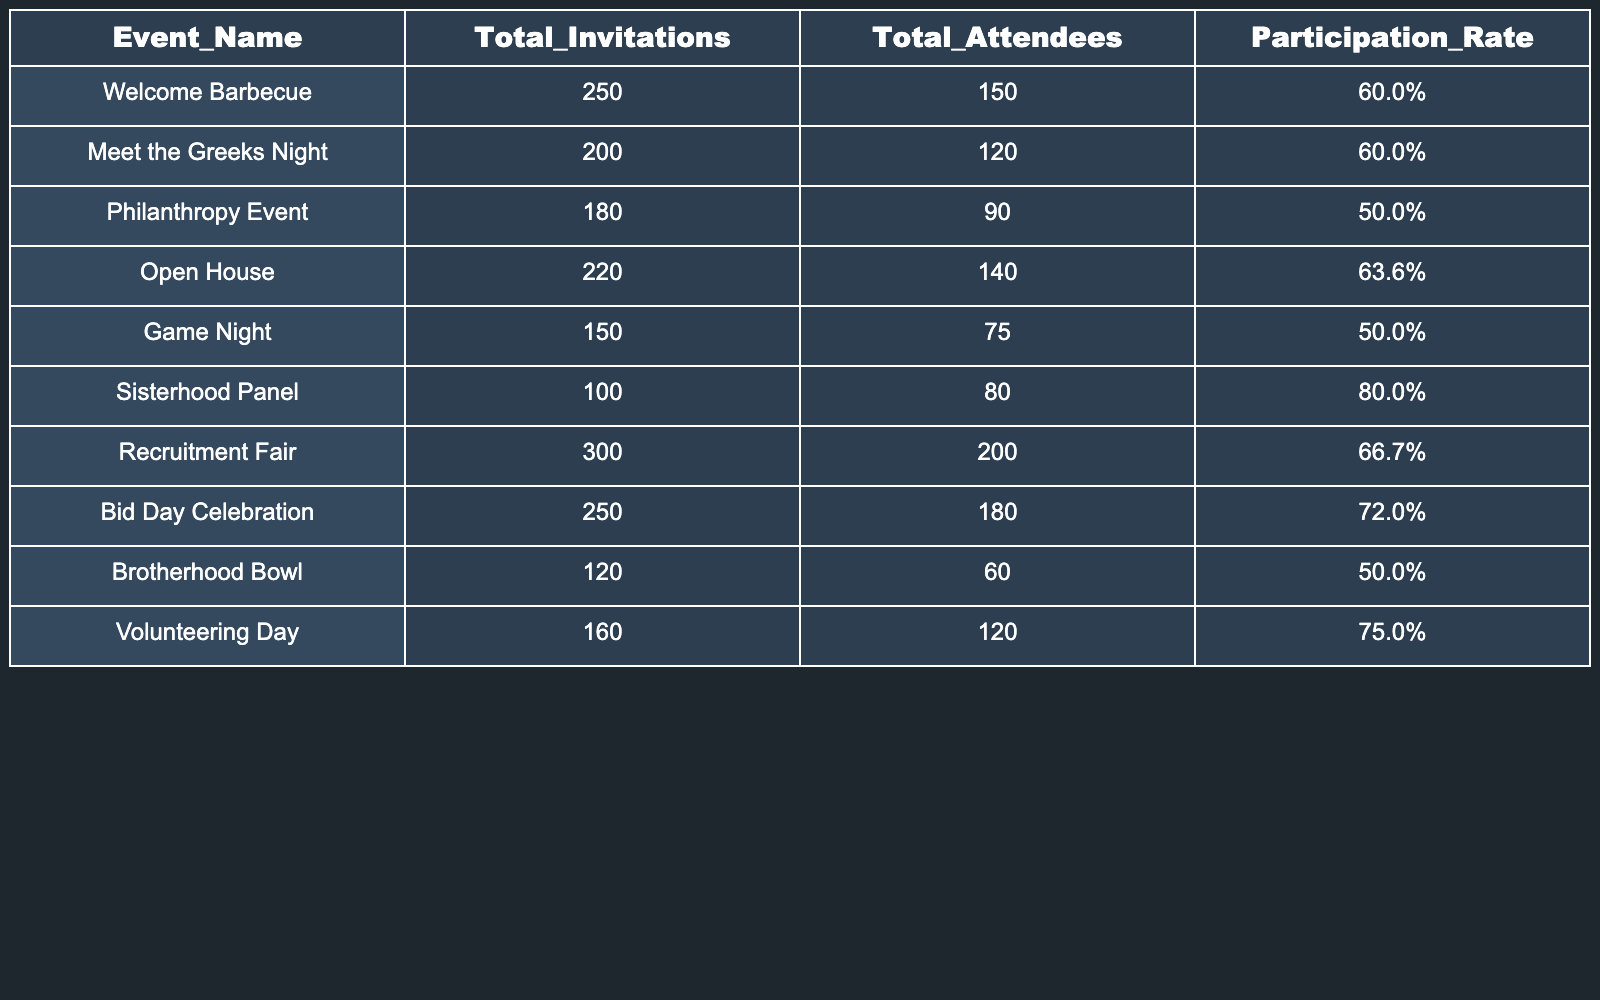What's the participation rate for the Sisterhood Panel? The table shows that the Sisterhood Panel has a participation rate listed as 80.0%.
Answer: 80.0% Which event had the highest total number of attendees? The table indicates that the event with the highest total attendees is the Recruitment Fair, with 200 attendees.
Answer: Recruitment Fair How many more attendees did the Bid Day Celebration have compared to the Game Night? The Bid Day Celebration had 180 attendees and the Game Night had 75 attendees. The difference is 180 - 75 = 105 attendees.
Answer: 105 What is the average participation rate of all events listed? The participation rates for the events are 60.0%, 60.0%, 50.0%, 63.6%, 50.0%, 80.0%, 66.7%, 72.0%, 50.0%, and 75.0%. Summing these rates gives 637.3%. Dividing by 10 (the number of events) results in an average of 63.73%.
Answer: 63.73% Are there any events with a participation rate lower than 55%? By reviewing the participation rates, the Philanthropy Event, Game Night, and Brotherhood Bowl all have participation rates of 50.0%, which is lower than 55%. Therefore, the answer is yes.
Answer: Yes Which event had the lowest total invitations? The Brotherhood Bowl has the lowest total invitations, which is 120.
Answer: Brotherhood Bowl If you combine the total attendees of the Welcome Barbecue and Open House, what is the total? The Welcome Barbecue had 150 attendees and the Open House had 140 attendees. Adding these gives 150 + 140 = 290 total attendees.
Answer: 290 Is the participation rate for the Volunteering Day higher than the average participation rate of the events? The average participation rate is 63.73%, and the Volunteering Day has a participation rate of 75.0%, which is higher than the average. Thus, the answer is yes.
Answer: Yes What percentage of Total Invitations were actual attendees for the Game Night? The Game Night had 150 total invitations and 75 total attendees. To find the percentage, calculate (75 / 150) * 100 = 50%.
Answer: 50% Which events have a participation rate of 60% or higher? Scanning the participation rates, the events with 60% or higher are the Welcome Barbecue, Meet the Greeks Night, Open House, Sisterhood Panel, Recruitment Fair, Bid Day Celebration, and Volunteering Day. Counting these gives 7 events.
Answer: 7 events 